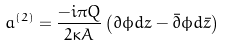<formula> <loc_0><loc_0><loc_500><loc_500>a ^ { \left ( 2 \right ) } = \frac { - i \pi Q } { 2 \kappa A } \left ( \partial \phi d z - { \bar { \partial } } \phi d { \bar { z } } \right )</formula> 